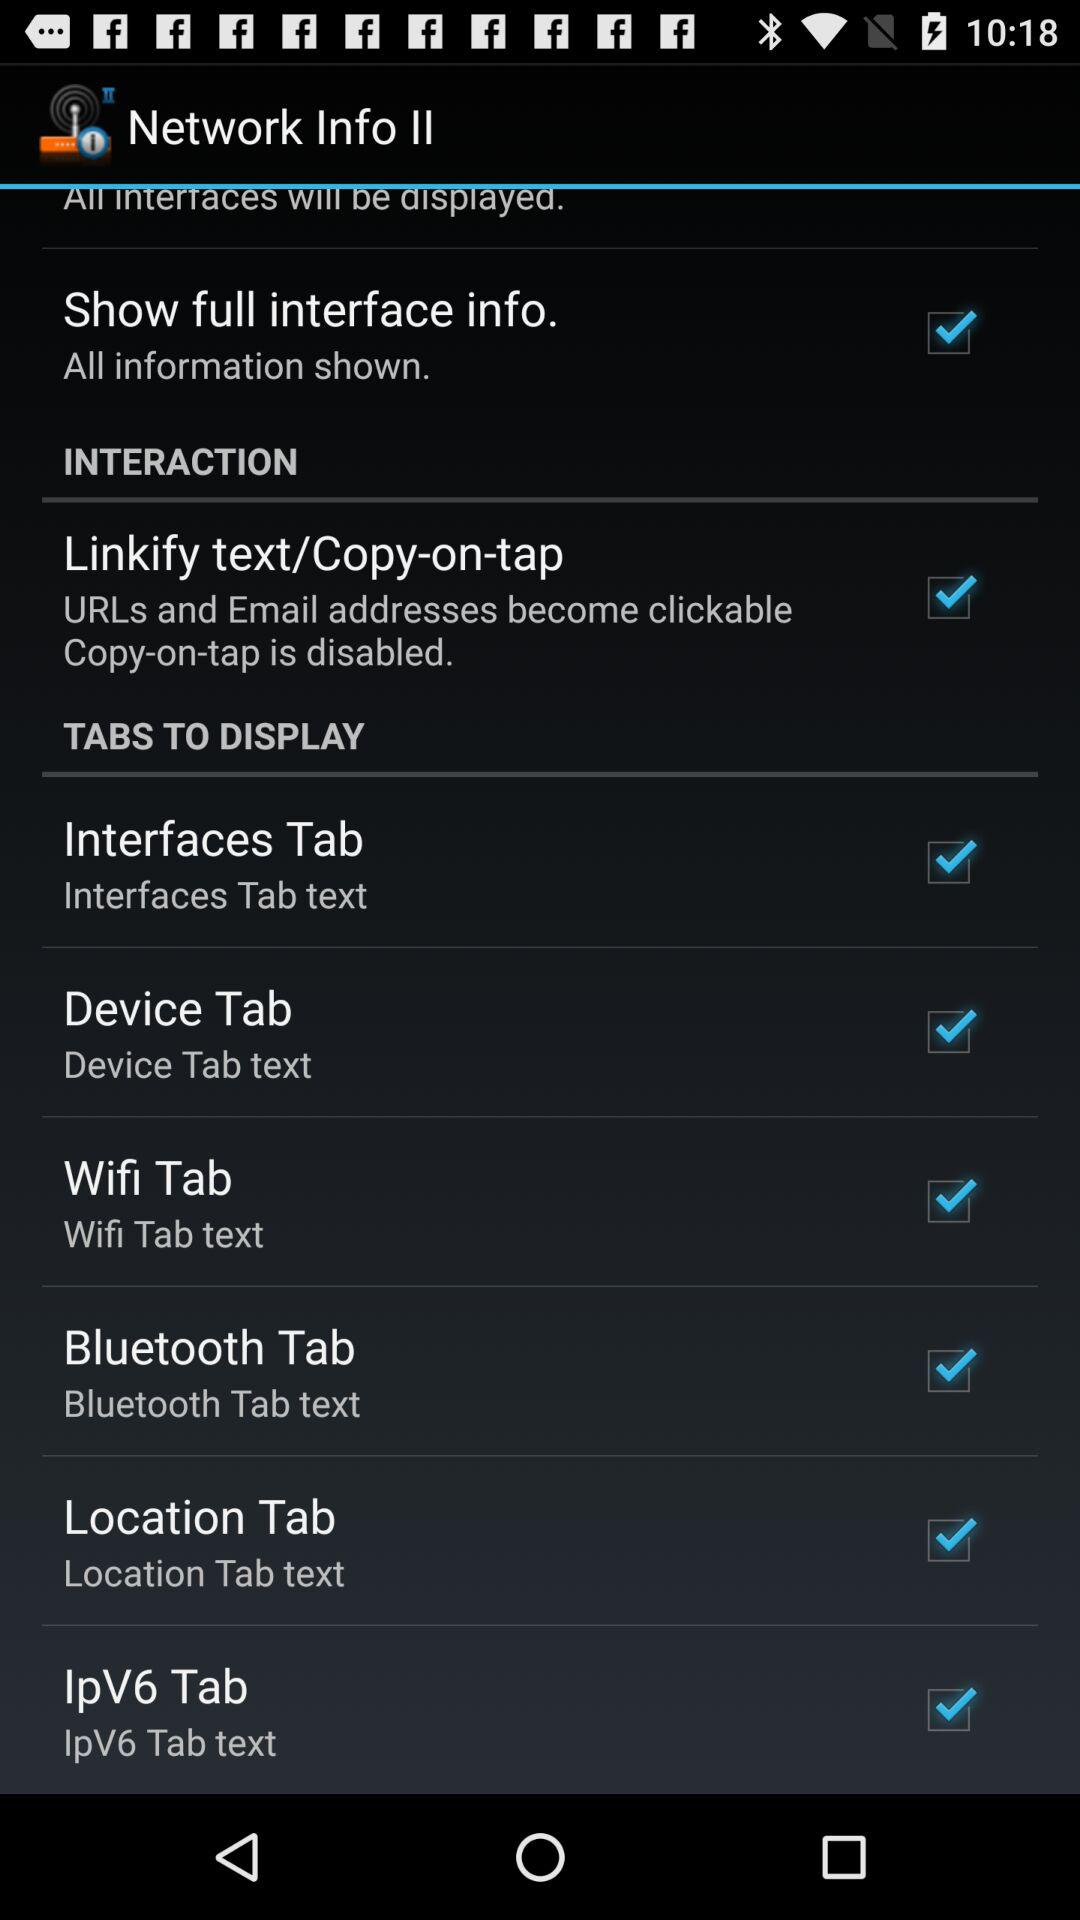How many tabs are there in the tabs to display section?
Answer the question using a single word or phrase. 6 